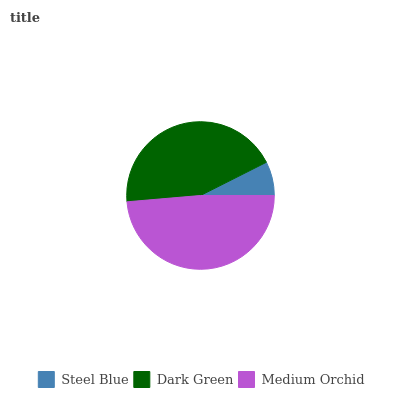Is Steel Blue the minimum?
Answer yes or no. Yes. Is Medium Orchid the maximum?
Answer yes or no. Yes. Is Dark Green the minimum?
Answer yes or no. No. Is Dark Green the maximum?
Answer yes or no. No. Is Dark Green greater than Steel Blue?
Answer yes or no. Yes. Is Steel Blue less than Dark Green?
Answer yes or no. Yes. Is Steel Blue greater than Dark Green?
Answer yes or no. No. Is Dark Green less than Steel Blue?
Answer yes or no. No. Is Dark Green the high median?
Answer yes or no. Yes. Is Dark Green the low median?
Answer yes or no. Yes. Is Steel Blue the high median?
Answer yes or no. No. Is Medium Orchid the low median?
Answer yes or no. No. 